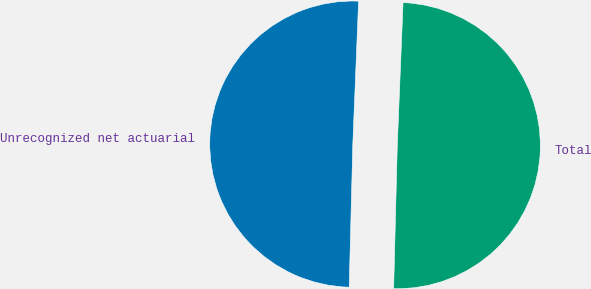Convert chart to OTSL. <chart><loc_0><loc_0><loc_500><loc_500><pie_chart><fcel>Unrecognized net actuarial<fcel>Total<nl><fcel>50.24%<fcel>49.76%<nl></chart> 